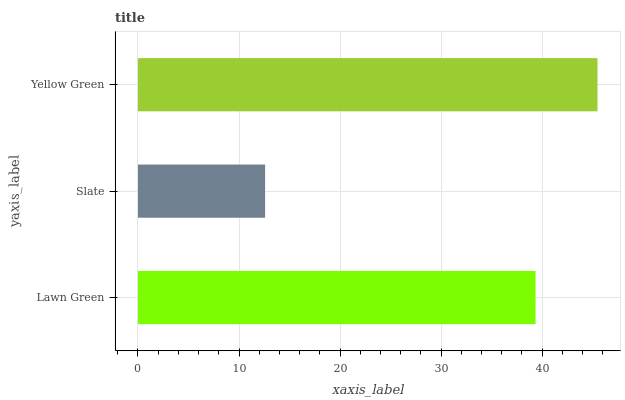Is Slate the minimum?
Answer yes or no. Yes. Is Yellow Green the maximum?
Answer yes or no. Yes. Is Yellow Green the minimum?
Answer yes or no. No. Is Slate the maximum?
Answer yes or no. No. Is Yellow Green greater than Slate?
Answer yes or no. Yes. Is Slate less than Yellow Green?
Answer yes or no. Yes. Is Slate greater than Yellow Green?
Answer yes or no. No. Is Yellow Green less than Slate?
Answer yes or no. No. Is Lawn Green the high median?
Answer yes or no. Yes. Is Lawn Green the low median?
Answer yes or no. Yes. Is Slate the high median?
Answer yes or no. No. Is Yellow Green the low median?
Answer yes or no. No. 